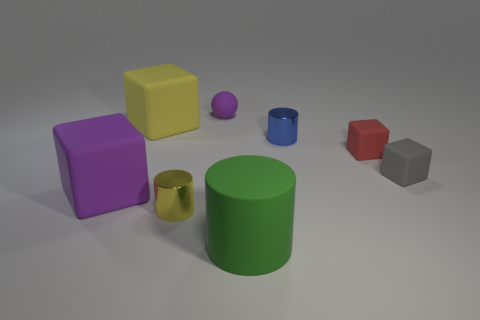How many tiny objects are either purple spheres or blue metal cylinders?
Give a very brief answer. 2. Is there a rubber cube that has the same color as the small matte sphere?
Make the answer very short. Yes. What is the shape of the green rubber object that is the same size as the purple rubber cube?
Offer a very short reply. Cylinder. Is the color of the metallic object that is on the right side of the tiny purple object the same as the matte cylinder?
Your answer should be compact. No. What number of objects are either yellow things that are to the right of the big yellow rubber cube or large objects?
Your answer should be very brief. 4. Are there more large green cylinders that are to the right of the small red object than large purple rubber cubes to the right of the big yellow rubber object?
Offer a terse response. No. Are the blue object and the large purple object made of the same material?
Ensure brevity in your answer.  No. What shape is the object that is both in front of the purple rubber block and behind the green rubber object?
Make the answer very short. Cylinder. The purple thing that is the same material as the large purple cube is what shape?
Ensure brevity in your answer.  Sphere. Are there any blue objects?
Keep it short and to the point. Yes. 